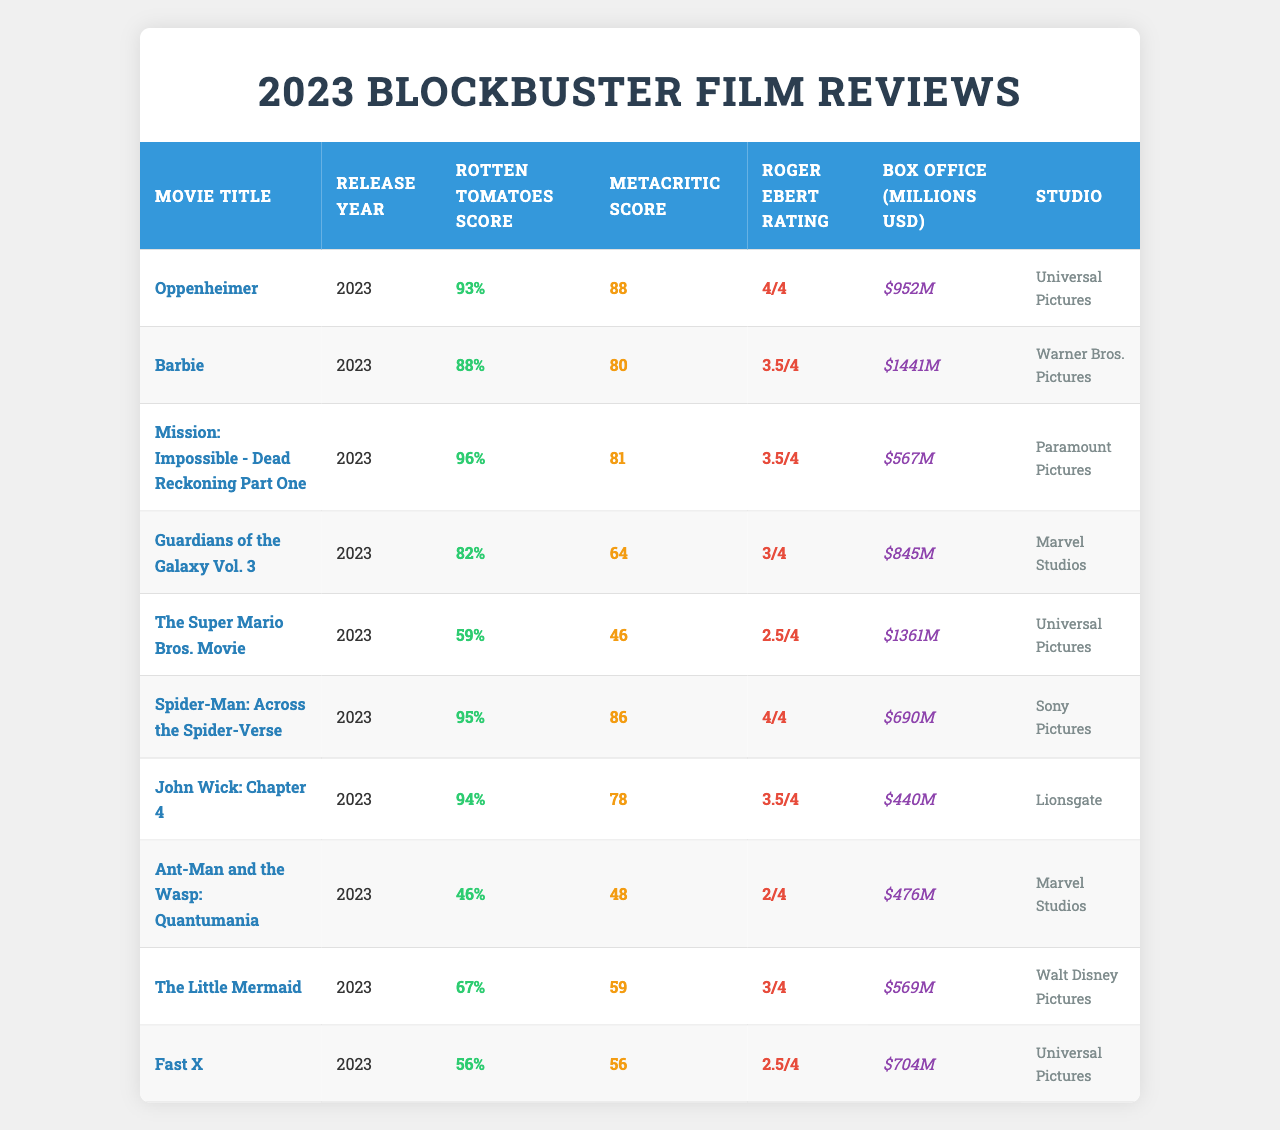What is the Rotten Tomatoes score of "Oppenheimer"? The Rotten Tomatoes score for "Oppenheimer" is located in the table under the respective column for the movie. It shows a score of 93%.
Answer: 93% Which movie had the highest box office earnings? The box office earnings for all movies can be compared in the table. "Barbie" has the highest earnings of $1441 million.
Answer: $1441 million What is the Metacritic score for "Mission: Impossible - Dead Reckoning Part One"? By looking at the table, "Mission: Impossible - Dead Reckoning Part One" has a Metacritic score of 81.
Answer: 81 Which movie received the lowest Rotten Tomatoes score? By reviewing the Rotten Tomatoes scores in the table, "Ant-Man and the Wasp: Quantumania" has the lowest score of 46%.
Answer: 46% What is the average Roger Ebert rating for movies in 2023? The Roger Ebert ratings can be summed up from each movie: (4 + 3.5 + 3.5 + 3 + 2.5 + 4 + 3.5 + 2 + 3 + 2.5) = 30. The average is then calculated as 30/10 = 3.
Answer: 3 Is "Spider-Man: Across the Spider-Verse" rated higher than "John Wick: Chapter 4" by Rotten Tomatoes? Comparing the Rotten Tomatoes scores for both movies reveals that "Spider-Man: Across the Spider-Verse" has a score of 95%, while "John Wick: Chapter 4" has a score of 94%. Therefore, yes, "Spider-Man" is rated higher.
Answer: Yes What is the box office difference between "Guardians of the Galaxy Vol. 3" and "Fast X"? The box office earnings from the table are $845 million for "Guardians of the Galaxy Vol. 3" and $704 million for "Fast X". The difference is calculated as 845 - 704 = 141 million.
Answer: $141 million How many movies have a Rotten Tomatoes score above 90%? In the table, the movies with Rotten Tomatoes scores above 90% are "Oppenheimer" (93%), "Mission: Impossible - Dead Reckoning Part One" (96%), and "Spider-Man: Across the Spider-Verse" (95%). There are three such movies.
Answer: 3 Which studio released the movie with the highest Metacritic score? By examining the Metacritic scores, "Oppenheimer" has the highest score of 88, and it was released by "Universal Pictures".
Answer: Universal Pictures Is the average box office for movies rated lower than 70% on Rotten Tomatoes greater than that of movies rated higher? Analyzing the box office for movies rated lower than 70% (The Super Mario Bros. Movie, Ant-Man and the Wasp: Quantumania, The Little Mermaid, and Fast X), we find the average is (1361 + 476 + 569 + 704)/4 = 777.5 million. For those rated higher than 70% (Oppenheimer, Barbie, Mission Impossible, Guardians of the Galaxy, Spider-Man, John Wick), the average is (952 + 1441 + 567 + 845 + 690 + 440)/6 = 745. The average for lower rated movies is greater than higher rated ones.
Answer: Yes 